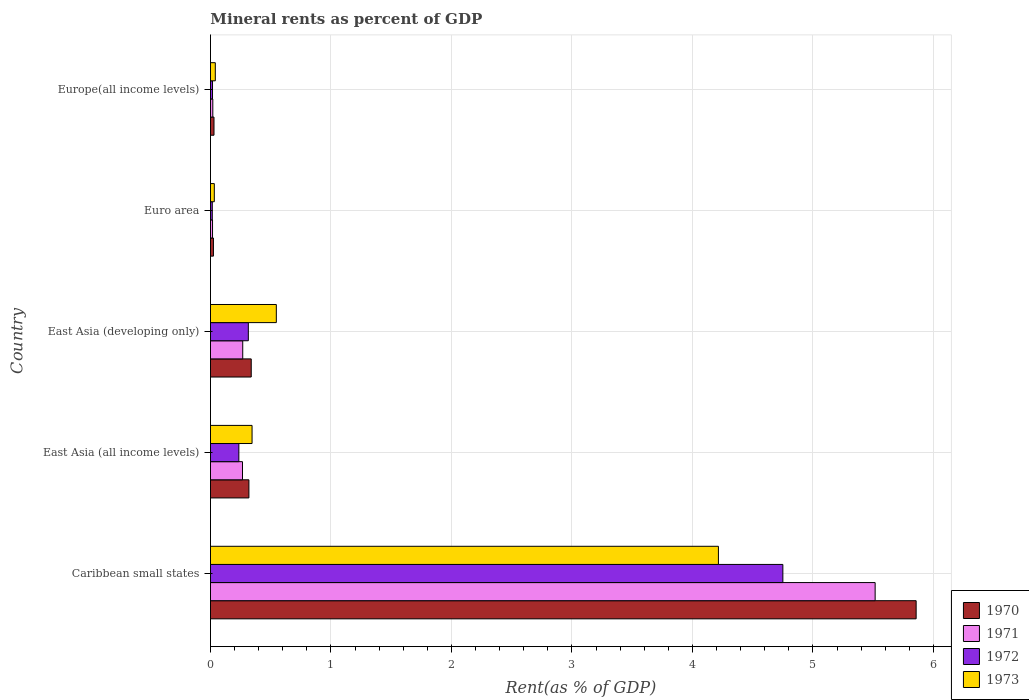How many different coloured bars are there?
Offer a terse response. 4. How many bars are there on the 5th tick from the top?
Provide a short and direct response. 4. What is the label of the 4th group of bars from the top?
Ensure brevity in your answer.  East Asia (all income levels). In how many cases, is the number of bars for a given country not equal to the number of legend labels?
Ensure brevity in your answer.  0. What is the mineral rent in 1972 in Europe(all income levels)?
Offer a terse response. 0.02. Across all countries, what is the maximum mineral rent in 1973?
Keep it short and to the point. 4.22. Across all countries, what is the minimum mineral rent in 1973?
Your answer should be very brief. 0.03. In which country was the mineral rent in 1972 maximum?
Make the answer very short. Caribbean small states. What is the total mineral rent in 1972 in the graph?
Provide a succinct answer. 5.33. What is the difference between the mineral rent in 1971 in Caribbean small states and that in Euro area?
Give a very brief answer. 5.5. What is the difference between the mineral rent in 1973 in Euro area and the mineral rent in 1970 in Caribbean small states?
Provide a short and direct response. -5.82. What is the average mineral rent in 1973 per country?
Provide a succinct answer. 1.04. What is the difference between the mineral rent in 1972 and mineral rent in 1970 in Europe(all income levels)?
Make the answer very short. -0.01. What is the ratio of the mineral rent in 1971 in Euro area to that in Europe(all income levels)?
Your answer should be compact. 0.88. Is the mineral rent in 1973 in East Asia (developing only) less than that in Euro area?
Ensure brevity in your answer.  No. Is the difference between the mineral rent in 1972 in East Asia (developing only) and Europe(all income levels) greater than the difference between the mineral rent in 1970 in East Asia (developing only) and Europe(all income levels)?
Your response must be concise. No. What is the difference between the highest and the second highest mineral rent in 1973?
Provide a succinct answer. 3.67. What is the difference between the highest and the lowest mineral rent in 1971?
Provide a short and direct response. 5.5. Is the sum of the mineral rent in 1971 in East Asia (all income levels) and East Asia (developing only) greater than the maximum mineral rent in 1973 across all countries?
Provide a short and direct response. No. Is it the case that in every country, the sum of the mineral rent in 1972 and mineral rent in 1973 is greater than the sum of mineral rent in 1970 and mineral rent in 1971?
Make the answer very short. No. What does the 2nd bar from the top in Caribbean small states represents?
Keep it short and to the point. 1972. What does the 4th bar from the bottom in Europe(all income levels) represents?
Provide a short and direct response. 1973. How many bars are there?
Ensure brevity in your answer.  20. Are all the bars in the graph horizontal?
Provide a short and direct response. Yes. How many countries are there in the graph?
Your answer should be compact. 5. Does the graph contain any zero values?
Give a very brief answer. No. How many legend labels are there?
Provide a short and direct response. 4. How are the legend labels stacked?
Provide a short and direct response. Vertical. What is the title of the graph?
Provide a short and direct response. Mineral rents as percent of GDP. Does "1980" appear as one of the legend labels in the graph?
Ensure brevity in your answer.  No. What is the label or title of the X-axis?
Offer a very short reply. Rent(as % of GDP). What is the label or title of the Y-axis?
Ensure brevity in your answer.  Country. What is the Rent(as % of GDP) in 1970 in Caribbean small states?
Your response must be concise. 5.86. What is the Rent(as % of GDP) of 1971 in Caribbean small states?
Offer a terse response. 5.52. What is the Rent(as % of GDP) in 1972 in Caribbean small states?
Make the answer very short. 4.75. What is the Rent(as % of GDP) in 1973 in Caribbean small states?
Provide a succinct answer. 4.22. What is the Rent(as % of GDP) of 1970 in East Asia (all income levels)?
Your response must be concise. 0.32. What is the Rent(as % of GDP) in 1971 in East Asia (all income levels)?
Keep it short and to the point. 0.27. What is the Rent(as % of GDP) of 1972 in East Asia (all income levels)?
Provide a succinct answer. 0.24. What is the Rent(as % of GDP) of 1973 in East Asia (all income levels)?
Provide a succinct answer. 0.35. What is the Rent(as % of GDP) of 1970 in East Asia (developing only)?
Your answer should be compact. 0.34. What is the Rent(as % of GDP) of 1971 in East Asia (developing only)?
Ensure brevity in your answer.  0.27. What is the Rent(as % of GDP) of 1972 in East Asia (developing only)?
Provide a short and direct response. 0.31. What is the Rent(as % of GDP) of 1973 in East Asia (developing only)?
Offer a terse response. 0.55. What is the Rent(as % of GDP) of 1970 in Euro area?
Offer a very short reply. 0.02. What is the Rent(as % of GDP) in 1971 in Euro area?
Your answer should be very brief. 0.02. What is the Rent(as % of GDP) of 1972 in Euro area?
Offer a terse response. 0.02. What is the Rent(as % of GDP) of 1973 in Euro area?
Offer a terse response. 0.03. What is the Rent(as % of GDP) of 1970 in Europe(all income levels)?
Offer a very short reply. 0.03. What is the Rent(as % of GDP) of 1971 in Europe(all income levels)?
Your response must be concise. 0.02. What is the Rent(as % of GDP) of 1972 in Europe(all income levels)?
Offer a terse response. 0.02. What is the Rent(as % of GDP) of 1973 in Europe(all income levels)?
Offer a terse response. 0.04. Across all countries, what is the maximum Rent(as % of GDP) in 1970?
Keep it short and to the point. 5.86. Across all countries, what is the maximum Rent(as % of GDP) in 1971?
Your answer should be compact. 5.52. Across all countries, what is the maximum Rent(as % of GDP) in 1972?
Your answer should be very brief. 4.75. Across all countries, what is the maximum Rent(as % of GDP) in 1973?
Your answer should be very brief. 4.22. Across all countries, what is the minimum Rent(as % of GDP) in 1970?
Provide a succinct answer. 0.02. Across all countries, what is the minimum Rent(as % of GDP) in 1971?
Provide a succinct answer. 0.02. Across all countries, what is the minimum Rent(as % of GDP) of 1972?
Provide a short and direct response. 0.02. Across all countries, what is the minimum Rent(as % of GDP) in 1973?
Give a very brief answer. 0.03. What is the total Rent(as % of GDP) in 1970 in the graph?
Give a very brief answer. 6.57. What is the total Rent(as % of GDP) in 1971 in the graph?
Provide a succinct answer. 6.09. What is the total Rent(as % of GDP) of 1972 in the graph?
Offer a terse response. 5.33. What is the total Rent(as % of GDP) in 1973 in the graph?
Make the answer very short. 5.18. What is the difference between the Rent(as % of GDP) in 1970 in Caribbean small states and that in East Asia (all income levels)?
Offer a terse response. 5.54. What is the difference between the Rent(as % of GDP) in 1971 in Caribbean small states and that in East Asia (all income levels)?
Provide a short and direct response. 5.25. What is the difference between the Rent(as % of GDP) of 1972 in Caribbean small states and that in East Asia (all income levels)?
Give a very brief answer. 4.51. What is the difference between the Rent(as % of GDP) of 1973 in Caribbean small states and that in East Asia (all income levels)?
Offer a very short reply. 3.87. What is the difference between the Rent(as % of GDP) in 1970 in Caribbean small states and that in East Asia (developing only)?
Make the answer very short. 5.52. What is the difference between the Rent(as % of GDP) of 1971 in Caribbean small states and that in East Asia (developing only)?
Keep it short and to the point. 5.25. What is the difference between the Rent(as % of GDP) of 1972 in Caribbean small states and that in East Asia (developing only)?
Provide a succinct answer. 4.44. What is the difference between the Rent(as % of GDP) of 1973 in Caribbean small states and that in East Asia (developing only)?
Offer a very short reply. 3.67. What is the difference between the Rent(as % of GDP) of 1970 in Caribbean small states and that in Euro area?
Keep it short and to the point. 5.83. What is the difference between the Rent(as % of GDP) in 1971 in Caribbean small states and that in Euro area?
Give a very brief answer. 5.5. What is the difference between the Rent(as % of GDP) of 1972 in Caribbean small states and that in Euro area?
Keep it short and to the point. 4.74. What is the difference between the Rent(as % of GDP) in 1973 in Caribbean small states and that in Euro area?
Give a very brief answer. 4.18. What is the difference between the Rent(as % of GDP) of 1970 in Caribbean small states and that in Europe(all income levels)?
Offer a very short reply. 5.83. What is the difference between the Rent(as % of GDP) of 1971 in Caribbean small states and that in Europe(all income levels)?
Make the answer very short. 5.5. What is the difference between the Rent(as % of GDP) of 1972 in Caribbean small states and that in Europe(all income levels)?
Make the answer very short. 4.73. What is the difference between the Rent(as % of GDP) in 1973 in Caribbean small states and that in Europe(all income levels)?
Ensure brevity in your answer.  4.18. What is the difference between the Rent(as % of GDP) in 1970 in East Asia (all income levels) and that in East Asia (developing only)?
Make the answer very short. -0.02. What is the difference between the Rent(as % of GDP) in 1971 in East Asia (all income levels) and that in East Asia (developing only)?
Ensure brevity in your answer.  -0. What is the difference between the Rent(as % of GDP) in 1972 in East Asia (all income levels) and that in East Asia (developing only)?
Keep it short and to the point. -0.08. What is the difference between the Rent(as % of GDP) of 1973 in East Asia (all income levels) and that in East Asia (developing only)?
Your response must be concise. -0.2. What is the difference between the Rent(as % of GDP) of 1970 in East Asia (all income levels) and that in Euro area?
Make the answer very short. 0.29. What is the difference between the Rent(as % of GDP) of 1971 in East Asia (all income levels) and that in Euro area?
Ensure brevity in your answer.  0.25. What is the difference between the Rent(as % of GDP) of 1972 in East Asia (all income levels) and that in Euro area?
Offer a very short reply. 0.22. What is the difference between the Rent(as % of GDP) of 1973 in East Asia (all income levels) and that in Euro area?
Your answer should be compact. 0.31. What is the difference between the Rent(as % of GDP) in 1970 in East Asia (all income levels) and that in Europe(all income levels)?
Provide a short and direct response. 0.29. What is the difference between the Rent(as % of GDP) of 1971 in East Asia (all income levels) and that in Europe(all income levels)?
Provide a short and direct response. 0.25. What is the difference between the Rent(as % of GDP) of 1972 in East Asia (all income levels) and that in Europe(all income levels)?
Offer a terse response. 0.22. What is the difference between the Rent(as % of GDP) of 1973 in East Asia (all income levels) and that in Europe(all income levels)?
Ensure brevity in your answer.  0.3. What is the difference between the Rent(as % of GDP) of 1970 in East Asia (developing only) and that in Euro area?
Offer a very short reply. 0.31. What is the difference between the Rent(as % of GDP) in 1971 in East Asia (developing only) and that in Euro area?
Give a very brief answer. 0.25. What is the difference between the Rent(as % of GDP) of 1972 in East Asia (developing only) and that in Euro area?
Your response must be concise. 0.3. What is the difference between the Rent(as % of GDP) in 1973 in East Asia (developing only) and that in Euro area?
Offer a terse response. 0.51. What is the difference between the Rent(as % of GDP) in 1970 in East Asia (developing only) and that in Europe(all income levels)?
Provide a short and direct response. 0.31. What is the difference between the Rent(as % of GDP) of 1971 in East Asia (developing only) and that in Europe(all income levels)?
Offer a very short reply. 0.25. What is the difference between the Rent(as % of GDP) in 1972 in East Asia (developing only) and that in Europe(all income levels)?
Keep it short and to the point. 0.3. What is the difference between the Rent(as % of GDP) in 1973 in East Asia (developing only) and that in Europe(all income levels)?
Provide a short and direct response. 0.51. What is the difference between the Rent(as % of GDP) of 1970 in Euro area and that in Europe(all income levels)?
Your response must be concise. -0. What is the difference between the Rent(as % of GDP) of 1971 in Euro area and that in Europe(all income levels)?
Offer a very short reply. -0. What is the difference between the Rent(as % of GDP) of 1972 in Euro area and that in Europe(all income levels)?
Provide a short and direct response. -0. What is the difference between the Rent(as % of GDP) in 1973 in Euro area and that in Europe(all income levels)?
Offer a terse response. -0.01. What is the difference between the Rent(as % of GDP) in 1970 in Caribbean small states and the Rent(as % of GDP) in 1971 in East Asia (all income levels)?
Your answer should be compact. 5.59. What is the difference between the Rent(as % of GDP) of 1970 in Caribbean small states and the Rent(as % of GDP) of 1972 in East Asia (all income levels)?
Offer a terse response. 5.62. What is the difference between the Rent(as % of GDP) of 1970 in Caribbean small states and the Rent(as % of GDP) of 1973 in East Asia (all income levels)?
Offer a terse response. 5.51. What is the difference between the Rent(as % of GDP) of 1971 in Caribbean small states and the Rent(as % of GDP) of 1972 in East Asia (all income levels)?
Ensure brevity in your answer.  5.28. What is the difference between the Rent(as % of GDP) in 1971 in Caribbean small states and the Rent(as % of GDP) in 1973 in East Asia (all income levels)?
Offer a terse response. 5.17. What is the difference between the Rent(as % of GDP) of 1972 in Caribbean small states and the Rent(as % of GDP) of 1973 in East Asia (all income levels)?
Your response must be concise. 4.41. What is the difference between the Rent(as % of GDP) of 1970 in Caribbean small states and the Rent(as % of GDP) of 1971 in East Asia (developing only)?
Provide a short and direct response. 5.59. What is the difference between the Rent(as % of GDP) in 1970 in Caribbean small states and the Rent(as % of GDP) in 1972 in East Asia (developing only)?
Keep it short and to the point. 5.54. What is the difference between the Rent(as % of GDP) of 1970 in Caribbean small states and the Rent(as % of GDP) of 1973 in East Asia (developing only)?
Your answer should be very brief. 5.31. What is the difference between the Rent(as % of GDP) of 1971 in Caribbean small states and the Rent(as % of GDP) of 1972 in East Asia (developing only)?
Your response must be concise. 5.2. What is the difference between the Rent(as % of GDP) in 1971 in Caribbean small states and the Rent(as % of GDP) in 1973 in East Asia (developing only)?
Your answer should be compact. 4.97. What is the difference between the Rent(as % of GDP) in 1972 in Caribbean small states and the Rent(as % of GDP) in 1973 in East Asia (developing only)?
Your response must be concise. 4.2. What is the difference between the Rent(as % of GDP) of 1970 in Caribbean small states and the Rent(as % of GDP) of 1971 in Euro area?
Give a very brief answer. 5.84. What is the difference between the Rent(as % of GDP) of 1970 in Caribbean small states and the Rent(as % of GDP) of 1972 in Euro area?
Make the answer very short. 5.84. What is the difference between the Rent(as % of GDP) of 1970 in Caribbean small states and the Rent(as % of GDP) of 1973 in Euro area?
Ensure brevity in your answer.  5.82. What is the difference between the Rent(as % of GDP) of 1971 in Caribbean small states and the Rent(as % of GDP) of 1972 in Euro area?
Your response must be concise. 5.5. What is the difference between the Rent(as % of GDP) of 1971 in Caribbean small states and the Rent(as % of GDP) of 1973 in Euro area?
Your answer should be very brief. 5.48. What is the difference between the Rent(as % of GDP) of 1972 in Caribbean small states and the Rent(as % of GDP) of 1973 in Euro area?
Give a very brief answer. 4.72. What is the difference between the Rent(as % of GDP) in 1970 in Caribbean small states and the Rent(as % of GDP) in 1971 in Europe(all income levels)?
Provide a short and direct response. 5.84. What is the difference between the Rent(as % of GDP) in 1970 in Caribbean small states and the Rent(as % of GDP) in 1972 in Europe(all income levels)?
Ensure brevity in your answer.  5.84. What is the difference between the Rent(as % of GDP) in 1970 in Caribbean small states and the Rent(as % of GDP) in 1973 in Europe(all income levels)?
Provide a succinct answer. 5.82. What is the difference between the Rent(as % of GDP) in 1971 in Caribbean small states and the Rent(as % of GDP) in 1972 in Europe(all income levels)?
Ensure brevity in your answer.  5.5. What is the difference between the Rent(as % of GDP) in 1971 in Caribbean small states and the Rent(as % of GDP) in 1973 in Europe(all income levels)?
Your response must be concise. 5.48. What is the difference between the Rent(as % of GDP) in 1972 in Caribbean small states and the Rent(as % of GDP) in 1973 in Europe(all income levels)?
Give a very brief answer. 4.71. What is the difference between the Rent(as % of GDP) in 1970 in East Asia (all income levels) and the Rent(as % of GDP) in 1971 in East Asia (developing only)?
Offer a terse response. 0.05. What is the difference between the Rent(as % of GDP) of 1970 in East Asia (all income levels) and the Rent(as % of GDP) of 1972 in East Asia (developing only)?
Ensure brevity in your answer.  0. What is the difference between the Rent(as % of GDP) of 1970 in East Asia (all income levels) and the Rent(as % of GDP) of 1973 in East Asia (developing only)?
Your answer should be very brief. -0.23. What is the difference between the Rent(as % of GDP) of 1971 in East Asia (all income levels) and the Rent(as % of GDP) of 1972 in East Asia (developing only)?
Your answer should be very brief. -0.05. What is the difference between the Rent(as % of GDP) in 1971 in East Asia (all income levels) and the Rent(as % of GDP) in 1973 in East Asia (developing only)?
Your response must be concise. -0.28. What is the difference between the Rent(as % of GDP) of 1972 in East Asia (all income levels) and the Rent(as % of GDP) of 1973 in East Asia (developing only)?
Your answer should be very brief. -0.31. What is the difference between the Rent(as % of GDP) of 1970 in East Asia (all income levels) and the Rent(as % of GDP) of 1971 in Euro area?
Make the answer very short. 0.3. What is the difference between the Rent(as % of GDP) in 1970 in East Asia (all income levels) and the Rent(as % of GDP) in 1972 in Euro area?
Offer a very short reply. 0.3. What is the difference between the Rent(as % of GDP) of 1970 in East Asia (all income levels) and the Rent(as % of GDP) of 1973 in Euro area?
Ensure brevity in your answer.  0.29. What is the difference between the Rent(as % of GDP) of 1971 in East Asia (all income levels) and the Rent(as % of GDP) of 1972 in Euro area?
Give a very brief answer. 0.25. What is the difference between the Rent(as % of GDP) in 1971 in East Asia (all income levels) and the Rent(as % of GDP) in 1973 in Euro area?
Give a very brief answer. 0.23. What is the difference between the Rent(as % of GDP) of 1972 in East Asia (all income levels) and the Rent(as % of GDP) of 1973 in Euro area?
Your response must be concise. 0.2. What is the difference between the Rent(as % of GDP) in 1970 in East Asia (all income levels) and the Rent(as % of GDP) in 1971 in Europe(all income levels)?
Offer a terse response. 0.3. What is the difference between the Rent(as % of GDP) in 1970 in East Asia (all income levels) and the Rent(as % of GDP) in 1972 in Europe(all income levels)?
Make the answer very short. 0.3. What is the difference between the Rent(as % of GDP) of 1970 in East Asia (all income levels) and the Rent(as % of GDP) of 1973 in Europe(all income levels)?
Offer a very short reply. 0.28. What is the difference between the Rent(as % of GDP) in 1971 in East Asia (all income levels) and the Rent(as % of GDP) in 1972 in Europe(all income levels)?
Provide a succinct answer. 0.25. What is the difference between the Rent(as % of GDP) in 1971 in East Asia (all income levels) and the Rent(as % of GDP) in 1973 in Europe(all income levels)?
Make the answer very short. 0.23. What is the difference between the Rent(as % of GDP) in 1972 in East Asia (all income levels) and the Rent(as % of GDP) in 1973 in Europe(all income levels)?
Give a very brief answer. 0.2. What is the difference between the Rent(as % of GDP) of 1970 in East Asia (developing only) and the Rent(as % of GDP) of 1971 in Euro area?
Your answer should be very brief. 0.32. What is the difference between the Rent(as % of GDP) of 1970 in East Asia (developing only) and the Rent(as % of GDP) of 1972 in Euro area?
Give a very brief answer. 0.32. What is the difference between the Rent(as % of GDP) in 1970 in East Asia (developing only) and the Rent(as % of GDP) in 1973 in Euro area?
Keep it short and to the point. 0.31. What is the difference between the Rent(as % of GDP) of 1971 in East Asia (developing only) and the Rent(as % of GDP) of 1972 in Euro area?
Your response must be concise. 0.25. What is the difference between the Rent(as % of GDP) of 1971 in East Asia (developing only) and the Rent(as % of GDP) of 1973 in Euro area?
Provide a short and direct response. 0.24. What is the difference between the Rent(as % of GDP) in 1972 in East Asia (developing only) and the Rent(as % of GDP) in 1973 in Euro area?
Your answer should be very brief. 0.28. What is the difference between the Rent(as % of GDP) of 1970 in East Asia (developing only) and the Rent(as % of GDP) of 1971 in Europe(all income levels)?
Provide a short and direct response. 0.32. What is the difference between the Rent(as % of GDP) of 1970 in East Asia (developing only) and the Rent(as % of GDP) of 1972 in Europe(all income levels)?
Your response must be concise. 0.32. What is the difference between the Rent(as % of GDP) of 1970 in East Asia (developing only) and the Rent(as % of GDP) of 1973 in Europe(all income levels)?
Provide a succinct answer. 0.3. What is the difference between the Rent(as % of GDP) of 1971 in East Asia (developing only) and the Rent(as % of GDP) of 1972 in Europe(all income levels)?
Provide a short and direct response. 0.25. What is the difference between the Rent(as % of GDP) in 1971 in East Asia (developing only) and the Rent(as % of GDP) in 1973 in Europe(all income levels)?
Give a very brief answer. 0.23. What is the difference between the Rent(as % of GDP) of 1972 in East Asia (developing only) and the Rent(as % of GDP) of 1973 in Europe(all income levels)?
Offer a very short reply. 0.27. What is the difference between the Rent(as % of GDP) in 1970 in Euro area and the Rent(as % of GDP) in 1971 in Europe(all income levels)?
Give a very brief answer. 0.01. What is the difference between the Rent(as % of GDP) of 1970 in Euro area and the Rent(as % of GDP) of 1972 in Europe(all income levels)?
Offer a very short reply. 0.01. What is the difference between the Rent(as % of GDP) of 1970 in Euro area and the Rent(as % of GDP) of 1973 in Europe(all income levels)?
Offer a very short reply. -0.02. What is the difference between the Rent(as % of GDP) in 1971 in Euro area and the Rent(as % of GDP) in 1973 in Europe(all income levels)?
Your answer should be very brief. -0.02. What is the difference between the Rent(as % of GDP) in 1972 in Euro area and the Rent(as % of GDP) in 1973 in Europe(all income levels)?
Keep it short and to the point. -0.03. What is the average Rent(as % of GDP) of 1970 per country?
Provide a succinct answer. 1.31. What is the average Rent(as % of GDP) of 1971 per country?
Your response must be concise. 1.22. What is the average Rent(as % of GDP) of 1972 per country?
Offer a very short reply. 1.07. What is the average Rent(as % of GDP) of 1973 per country?
Keep it short and to the point. 1.04. What is the difference between the Rent(as % of GDP) of 1970 and Rent(as % of GDP) of 1971 in Caribbean small states?
Your answer should be compact. 0.34. What is the difference between the Rent(as % of GDP) in 1970 and Rent(as % of GDP) in 1972 in Caribbean small states?
Keep it short and to the point. 1.11. What is the difference between the Rent(as % of GDP) of 1970 and Rent(as % of GDP) of 1973 in Caribbean small states?
Give a very brief answer. 1.64. What is the difference between the Rent(as % of GDP) of 1971 and Rent(as % of GDP) of 1972 in Caribbean small states?
Your answer should be very brief. 0.77. What is the difference between the Rent(as % of GDP) in 1971 and Rent(as % of GDP) in 1973 in Caribbean small states?
Make the answer very short. 1.3. What is the difference between the Rent(as % of GDP) of 1972 and Rent(as % of GDP) of 1973 in Caribbean small states?
Give a very brief answer. 0.53. What is the difference between the Rent(as % of GDP) in 1970 and Rent(as % of GDP) in 1971 in East Asia (all income levels)?
Ensure brevity in your answer.  0.05. What is the difference between the Rent(as % of GDP) of 1970 and Rent(as % of GDP) of 1972 in East Asia (all income levels)?
Your response must be concise. 0.08. What is the difference between the Rent(as % of GDP) in 1970 and Rent(as % of GDP) in 1973 in East Asia (all income levels)?
Offer a very short reply. -0.03. What is the difference between the Rent(as % of GDP) in 1971 and Rent(as % of GDP) in 1972 in East Asia (all income levels)?
Offer a terse response. 0.03. What is the difference between the Rent(as % of GDP) in 1971 and Rent(as % of GDP) in 1973 in East Asia (all income levels)?
Keep it short and to the point. -0.08. What is the difference between the Rent(as % of GDP) in 1972 and Rent(as % of GDP) in 1973 in East Asia (all income levels)?
Provide a succinct answer. -0.11. What is the difference between the Rent(as % of GDP) in 1970 and Rent(as % of GDP) in 1971 in East Asia (developing only)?
Provide a short and direct response. 0.07. What is the difference between the Rent(as % of GDP) in 1970 and Rent(as % of GDP) in 1972 in East Asia (developing only)?
Give a very brief answer. 0.02. What is the difference between the Rent(as % of GDP) of 1970 and Rent(as % of GDP) of 1973 in East Asia (developing only)?
Your answer should be compact. -0.21. What is the difference between the Rent(as % of GDP) in 1971 and Rent(as % of GDP) in 1972 in East Asia (developing only)?
Make the answer very short. -0.05. What is the difference between the Rent(as % of GDP) of 1971 and Rent(as % of GDP) of 1973 in East Asia (developing only)?
Give a very brief answer. -0.28. What is the difference between the Rent(as % of GDP) of 1972 and Rent(as % of GDP) of 1973 in East Asia (developing only)?
Provide a succinct answer. -0.23. What is the difference between the Rent(as % of GDP) in 1970 and Rent(as % of GDP) in 1971 in Euro area?
Provide a short and direct response. 0.01. What is the difference between the Rent(as % of GDP) of 1970 and Rent(as % of GDP) of 1972 in Euro area?
Your response must be concise. 0.01. What is the difference between the Rent(as % of GDP) of 1970 and Rent(as % of GDP) of 1973 in Euro area?
Your response must be concise. -0.01. What is the difference between the Rent(as % of GDP) in 1971 and Rent(as % of GDP) in 1972 in Euro area?
Make the answer very short. 0. What is the difference between the Rent(as % of GDP) in 1971 and Rent(as % of GDP) in 1973 in Euro area?
Your answer should be compact. -0.01. What is the difference between the Rent(as % of GDP) of 1972 and Rent(as % of GDP) of 1973 in Euro area?
Make the answer very short. -0.02. What is the difference between the Rent(as % of GDP) in 1970 and Rent(as % of GDP) in 1971 in Europe(all income levels)?
Your response must be concise. 0.01. What is the difference between the Rent(as % of GDP) of 1970 and Rent(as % of GDP) of 1972 in Europe(all income levels)?
Provide a succinct answer. 0.01. What is the difference between the Rent(as % of GDP) of 1970 and Rent(as % of GDP) of 1973 in Europe(all income levels)?
Offer a terse response. -0.01. What is the difference between the Rent(as % of GDP) of 1971 and Rent(as % of GDP) of 1972 in Europe(all income levels)?
Keep it short and to the point. 0. What is the difference between the Rent(as % of GDP) in 1971 and Rent(as % of GDP) in 1973 in Europe(all income levels)?
Give a very brief answer. -0.02. What is the difference between the Rent(as % of GDP) in 1972 and Rent(as % of GDP) in 1973 in Europe(all income levels)?
Offer a terse response. -0.02. What is the ratio of the Rent(as % of GDP) of 1970 in Caribbean small states to that in East Asia (all income levels)?
Your response must be concise. 18.36. What is the ratio of the Rent(as % of GDP) in 1971 in Caribbean small states to that in East Asia (all income levels)?
Your answer should be very brief. 20.76. What is the ratio of the Rent(as % of GDP) of 1972 in Caribbean small states to that in East Asia (all income levels)?
Make the answer very short. 20.18. What is the ratio of the Rent(as % of GDP) of 1973 in Caribbean small states to that in East Asia (all income levels)?
Offer a very short reply. 12.21. What is the ratio of the Rent(as % of GDP) of 1970 in Caribbean small states to that in East Asia (developing only)?
Your answer should be compact. 17.32. What is the ratio of the Rent(as % of GDP) of 1971 in Caribbean small states to that in East Asia (developing only)?
Keep it short and to the point. 20.61. What is the ratio of the Rent(as % of GDP) in 1972 in Caribbean small states to that in East Asia (developing only)?
Make the answer very short. 15.12. What is the ratio of the Rent(as % of GDP) of 1973 in Caribbean small states to that in East Asia (developing only)?
Give a very brief answer. 7.71. What is the ratio of the Rent(as % of GDP) in 1970 in Caribbean small states to that in Euro area?
Give a very brief answer. 238.3. What is the ratio of the Rent(as % of GDP) of 1971 in Caribbean small states to that in Euro area?
Offer a very short reply. 322.45. What is the ratio of the Rent(as % of GDP) in 1972 in Caribbean small states to that in Euro area?
Provide a succinct answer. 316.05. What is the ratio of the Rent(as % of GDP) of 1973 in Caribbean small states to that in Euro area?
Your answer should be very brief. 132.23. What is the ratio of the Rent(as % of GDP) of 1970 in Caribbean small states to that in Europe(all income levels)?
Make the answer very short. 199.94. What is the ratio of the Rent(as % of GDP) in 1971 in Caribbean small states to that in Europe(all income levels)?
Provide a succinct answer. 284.43. What is the ratio of the Rent(as % of GDP) of 1972 in Caribbean small states to that in Europe(all income levels)?
Make the answer very short. 279.99. What is the ratio of the Rent(as % of GDP) of 1973 in Caribbean small states to that in Europe(all income levels)?
Offer a terse response. 104.81. What is the ratio of the Rent(as % of GDP) of 1970 in East Asia (all income levels) to that in East Asia (developing only)?
Provide a succinct answer. 0.94. What is the ratio of the Rent(as % of GDP) in 1972 in East Asia (all income levels) to that in East Asia (developing only)?
Provide a short and direct response. 0.75. What is the ratio of the Rent(as % of GDP) in 1973 in East Asia (all income levels) to that in East Asia (developing only)?
Make the answer very short. 0.63. What is the ratio of the Rent(as % of GDP) of 1970 in East Asia (all income levels) to that in Euro area?
Your answer should be compact. 12.98. What is the ratio of the Rent(as % of GDP) of 1971 in East Asia (all income levels) to that in Euro area?
Ensure brevity in your answer.  15.54. What is the ratio of the Rent(as % of GDP) in 1972 in East Asia (all income levels) to that in Euro area?
Offer a terse response. 15.66. What is the ratio of the Rent(as % of GDP) of 1973 in East Asia (all income levels) to that in Euro area?
Provide a succinct answer. 10.83. What is the ratio of the Rent(as % of GDP) of 1970 in East Asia (all income levels) to that in Europe(all income levels)?
Keep it short and to the point. 10.89. What is the ratio of the Rent(as % of GDP) of 1971 in East Asia (all income levels) to that in Europe(all income levels)?
Ensure brevity in your answer.  13.7. What is the ratio of the Rent(as % of GDP) in 1972 in East Asia (all income levels) to that in Europe(all income levels)?
Keep it short and to the point. 13.88. What is the ratio of the Rent(as % of GDP) of 1973 in East Asia (all income levels) to that in Europe(all income levels)?
Provide a short and direct response. 8.58. What is the ratio of the Rent(as % of GDP) of 1970 in East Asia (developing only) to that in Euro area?
Ensure brevity in your answer.  13.76. What is the ratio of the Rent(as % of GDP) in 1971 in East Asia (developing only) to that in Euro area?
Offer a terse response. 15.65. What is the ratio of the Rent(as % of GDP) in 1972 in East Asia (developing only) to that in Euro area?
Offer a terse response. 20.91. What is the ratio of the Rent(as % of GDP) in 1973 in East Asia (developing only) to that in Euro area?
Offer a terse response. 17.14. What is the ratio of the Rent(as % of GDP) in 1970 in East Asia (developing only) to that in Europe(all income levels)?
Keep it short and to the point. 11.55. What is the ratio of the Rent(as % of GDP) of 1971 in East Asia (developing only) to that in Europe(all income levels)?
Your response must be concise. 13.8. What is the ratio of the Rent(as % of GDP) of 1972 in East Asia (developing only) to that in Europe(all income levels)?
Give a very brief answer. 18.52. What is the ratio of the Rent(as % of GDP) of 1973 in East Asia (developing only) to that in Europe(all income levels)?
Offer a terse response. 13.59. What is the ratio of the Rent(as % of GDP) in 1970 in Euro area to that in Europe(all income levels)?
Your response must be concise. 0.84. What is the ratio of the Rent(as % of GDP) in 1971 in Euro area to that in Europe(all income levels)?
Give a very brief answer. 0.88. What is the ratio of the Rent(as % of GDP) of 1972 in Euro area to that in Europe(all income levels)?
Give a very brief answer. 0.89. What is the ratio of the Rent(as % of GDP) in 1973 in Euro area to that in Europe(all income levels)?
Ensure brevity in your answer.  0.79. What is the difference between the highest and the second highest Rent(as % of GDP) of 1970?
Provide a short and direct response. 5.52. What is the difference between the highest and the second highest Rent(as % of GDP) of 1971?
Provide a short and direct response. 5.25. What is the difference between the highest and the second highest Rent(as % of GDP) of 1972?
Ensure brevity in your answer.  4.44. What is the difference between the highest and the second highest Rent(as % of GDP) in 1973?
Offer a very short reply. 3.67. What is the difference between the highest and the lowest Rent(as % of GDP) of 1970?
Your response must be concise. 5.83. What is the difference between the highest and the lowest Rent(as % of GDP) of 1971?
Provide a short and direct response. 5.5. What is the difference between the highest and the lowest Rent(as % of GDP) in 1972?
Your answer should be compact. 4.74. What is the difference between the highest and the lowest Rent(as % of GDP) in 1973?
Make the answer very short. 4.18. 